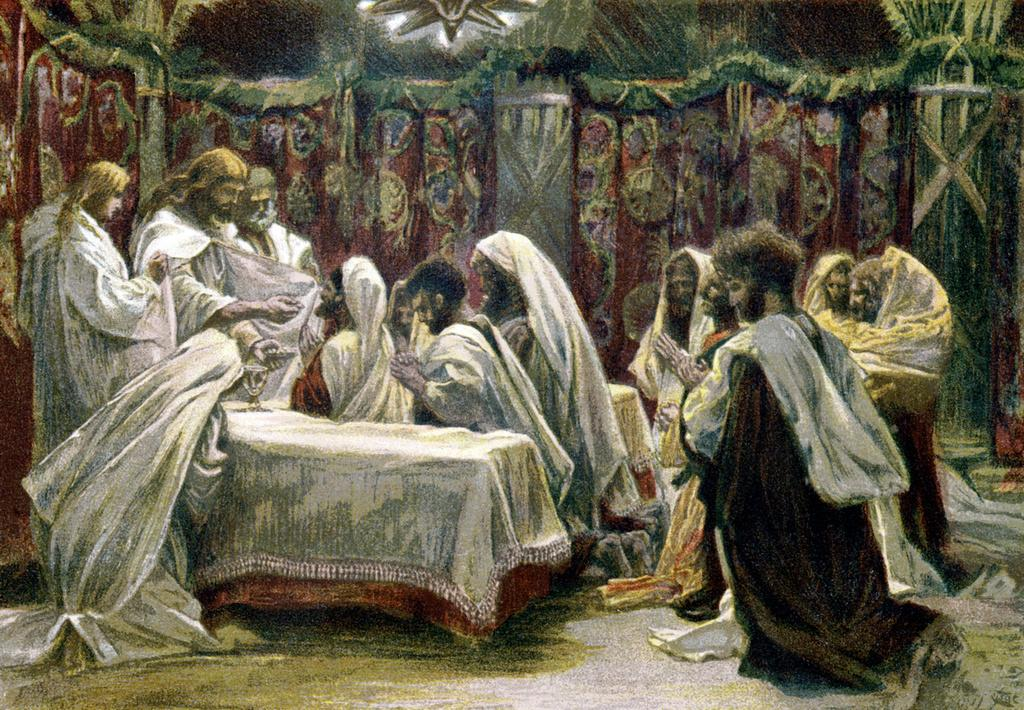What is the main subject of the image? There is a depiction of people in the image. Can you describe the clothing of the people in the image? Most of the people in the image are wearing white-colored dresses. What type of whip is being used by the people in the image? There is no whip present in the image; the people are wearing white-colored dresses. 